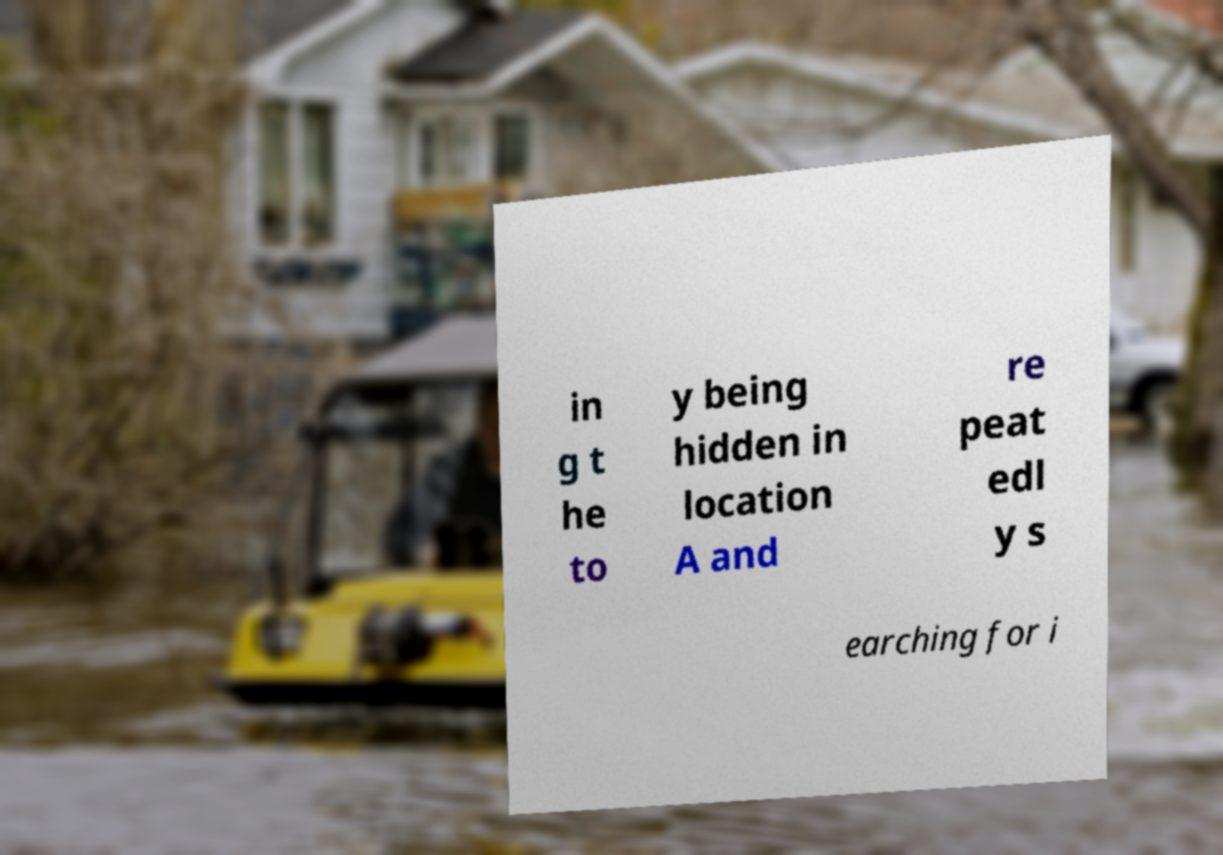For documentation purposes, I need the text within this image transcribed. Could you provide that? in g t he to y being hidden in location A and re peat edl y s earching for i 